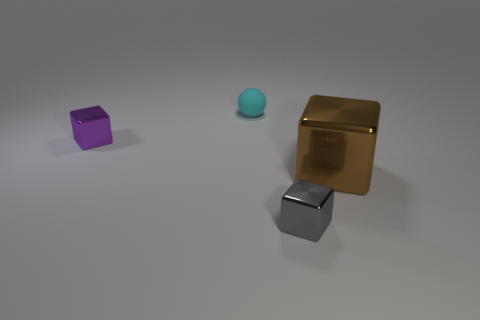Are there any other things that are made of the same material as the cyan sphere?
Make the answer very short. No. There is a metallic cube that is left of the gray metallic cube; is its size the same as the small rubber ball?
Make the answer very short. Yes. What material is the small gray thing that is in front of the big shiny cube?
Your answer should be compact. Metal. Are there the same number of shiny cubes that are on the right side of the cyan object and shiny cubes that are behind the small gray metal object?
Your answer should be compact. Yes. What is the color of the big thing that is the same shape as the small gray object?
Your answer should be very brief. Brown. Do the small cyan ball and the large object have the same material?
Give a very brief answer. No. There is a metal cube behind the big metal object; how many spheres are in front of it?
Offer a terse response. 0. Are there any brown metal objects of the same shape as the purple object?
Provide a succinct answer. Yes. Do the metal thing right of the small gray shiny thing and the thing that is in front of the brown shiny cube have the same shape?
Ensure brevity in your answer.  Yes. The metallic object that is to the left of the big thing and on the right side of the small cyan thing has what shape?
Offer a terse response. Cube. 